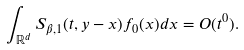Convert formula to latex. <formula><loc_0><loc_0><loc_500><loc_500>\int _ { \mathbb { R } ^ { d } } S _ { \beta , 1 } ( t , y - x ) f _ { 0 } ( x ) d x = O ( t ^ { 0 } ) .</formula> 